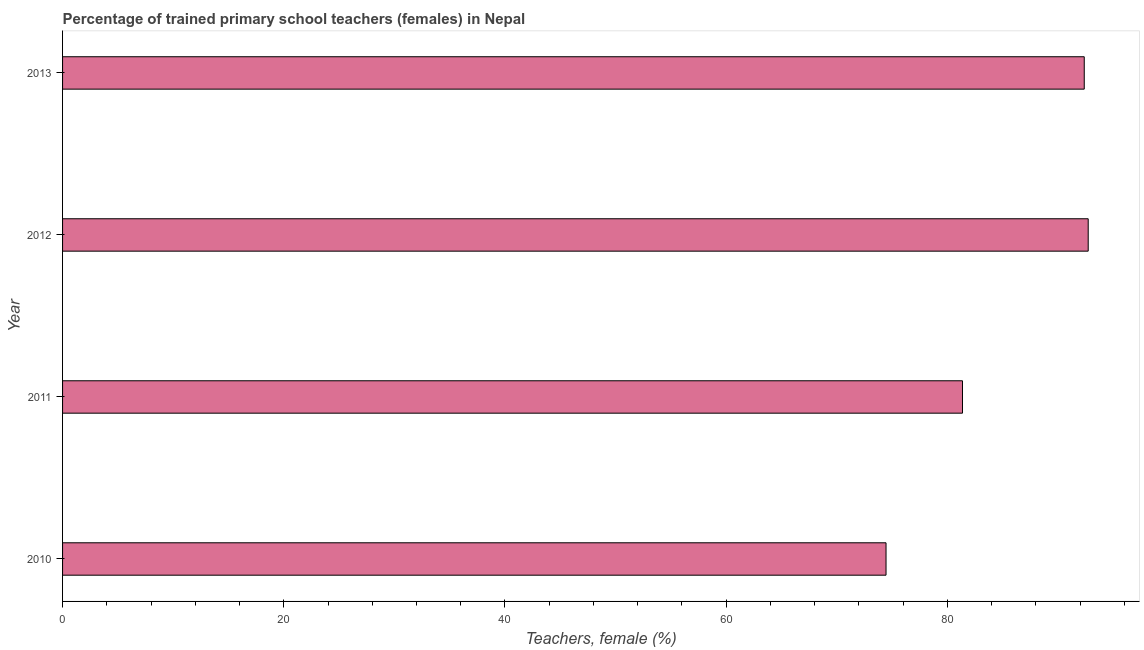Does the graph contain any zero values?
Your answer should be very brief. No. Does the graph contain grids?
Provide a short and direct response. No. What is the title of the graph?
Keep it short and to the point. Percentage of trained primary school teachers (females) in Nepal. What is the label or title of the X-axis?
Provide a short and direct response. Teachers, female (%). What is the percentage of trained female teachers in 2010?
Offer a very short reply. 74.46. Across all years, what is the maximum percentage of trained female teachers?
Your answer should be very brief. 92.74. Across all years, what is the minimum percentage of trained female teachers?
Offer a terse response. 74.46. In which year was the percentage of trained female teachers minimum?
Offer a very short reply. 2010. What is the sum of the percentage of trained female teachers?
Ensure brevity in your answer.  340.95. What is the difference between the percentage of trained female teachers in 2010 and 2011?
Your answer should be compact. -6.91. What is the average percentage of trained female teachers per year?
Offer a very short reply. 85.24. What is the median percentage of trained female teachers?
Ensure brevity in your answer.  86.87. In how many years, is the percentage of trained female teachers greater than 84 %?
Provide a short and direct response. 2. What is the ratio of the percentage of trained female teachers in 2010 to that in 2011?
Offer a very short reply. 0.92. Is the percentage of trained female teachers in 2011 less than that in 2012?
Make the answer very short. Yes. Is the difference between the percentage of trained female teachers in 2010 and 2013 greater than the difference between any two years?
Provide a succinct answer. No. What is the difference between the highest and the second highest percentage of trained female teachers?
Your response must be concise. 0.36. Is the sum of the percentage of trained female teachers in 2010 and 2013 greater than the maximum percentage of trained female teachers across all years?
Give a very brief answer. Yes. What is the difference between the highest and the lowest percentage of trained female teachers?
Keep it short and to the point. 18.28. In how many years, is the percentage of trained female teachers greater than the average percentage of trained female teachers taken over all years?
Give a very brief answer. 2. How many bars are there?
Offer a terse response. 4. How many years are there in the graph?
Offer a very short reply. 4. What is the difference between two consecutive major ticks on the X-axis?
Your answer should be very brief. 20. Are the values on the major ticks of X-axis written in scientific E-notation?
Offer a very short reply. No. What is the Teachers, female (%) in 2010?
Keep it short and to the point. 74.46. What is the Teachers, female (%) of 2011?
Your answer should be compact. 81.37. What is the Teachers, female (%) in 2012?
Ensure brevity in your answer.  92.74. What is the Teachers, female (%) in 2013?
Your answer should be very brief. 92.38. What is the difference between the Teachers, female (%) in 2010 and 2011?
Offer a terse response. -6.91. What is the difference between the Teachers, female (%) in 2010 and 2012?
Your response must be concise. -18.28. What is the difference between the Teachers, female (%) in 2010 and 2013?
Offer a terse response. -17.92. What is the difference between the Teachers, female (%) in 2011 and 2012?
Your answer should be compact. -11.37. What is the difference between the Teachers, female (%) in 2011 and 2013?
Keep it short and to the point. -11.01. What is the difference between the Teachers, female (%) in 2012 and 2013?
Provide a short and direct response. 0.36. What is the ratio of the Teachers, female (%) in 2010 to that in 2011?
Provide a short and direct response. 0.92. What is the ratio of the Teachers, female (%) in 2010 to that in 2012?
Your answer should be compact. 0.8. What is the ratio of the Teachers, female (%) in 2010 to that in 2013?
Provide a short and direct response. 0.81. What is the ratio of the Teachers, female (%) in 2011 to that in 2012?
Offer a terse response. 0.88. What is the ratio of the Teachers, female (%) in 2011 to that in 2013?
Your response must be concise. 0.88. What is the ratio of the Teachers, female (%) in 2012 to that in 2013?
Offer a very short reply. 1. 